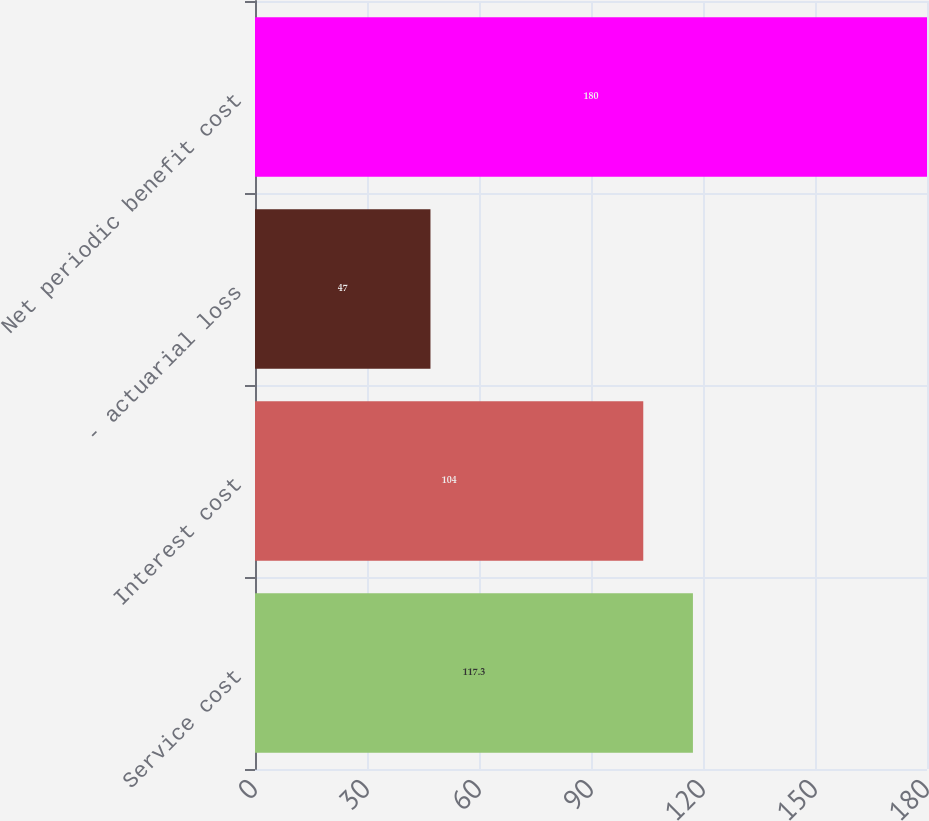Convert chart. <chart><loc_0><loc_0><loc_500><loc_500><bar_chart><fcel>Service cost<fcel>Interest cost<fcel>- actuarial loss<fcel>Net periodic benefit cost<nl><fcel>117.3<fcel>104<fcel>47<fcel>180<nl></chart> 